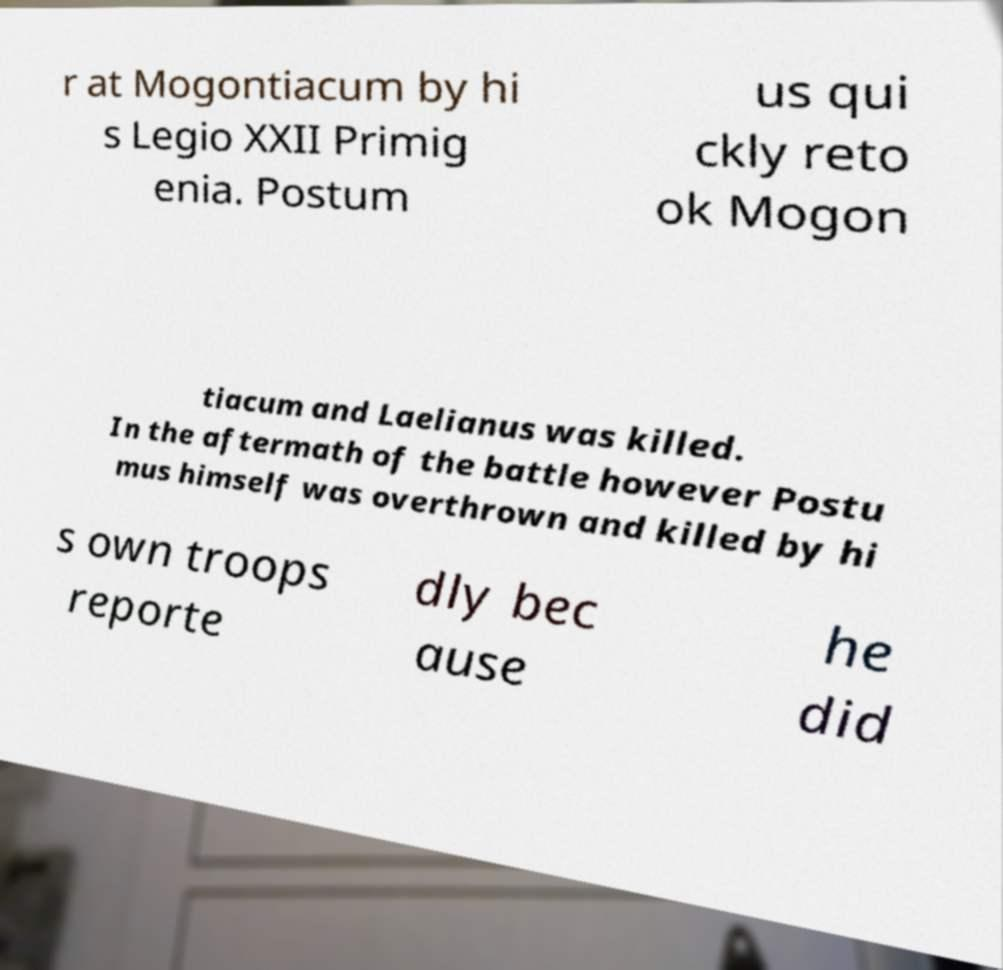Please read and relay the text visible in this image. What does it say? r at Mogontiacum by hi s Legio XXII Primig enia. Postum us qui ckly reto ok Mogon tiacum and Laelianus was killed. In the aftermath of the battle however Postu mus himself was overthrown and killed by hi s own troops reporte dly bec ause he did 